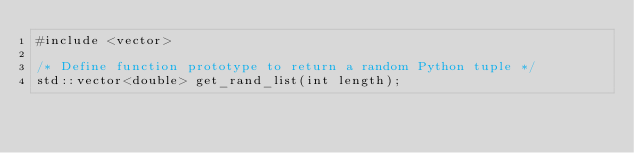<code> <loc_0><loc_0><loc_500><loc_500><_C_>#include <vector>

/* Define function prototype to return a random Python tuple */
std::vector<double> get_rand_list(int length);
</code> 